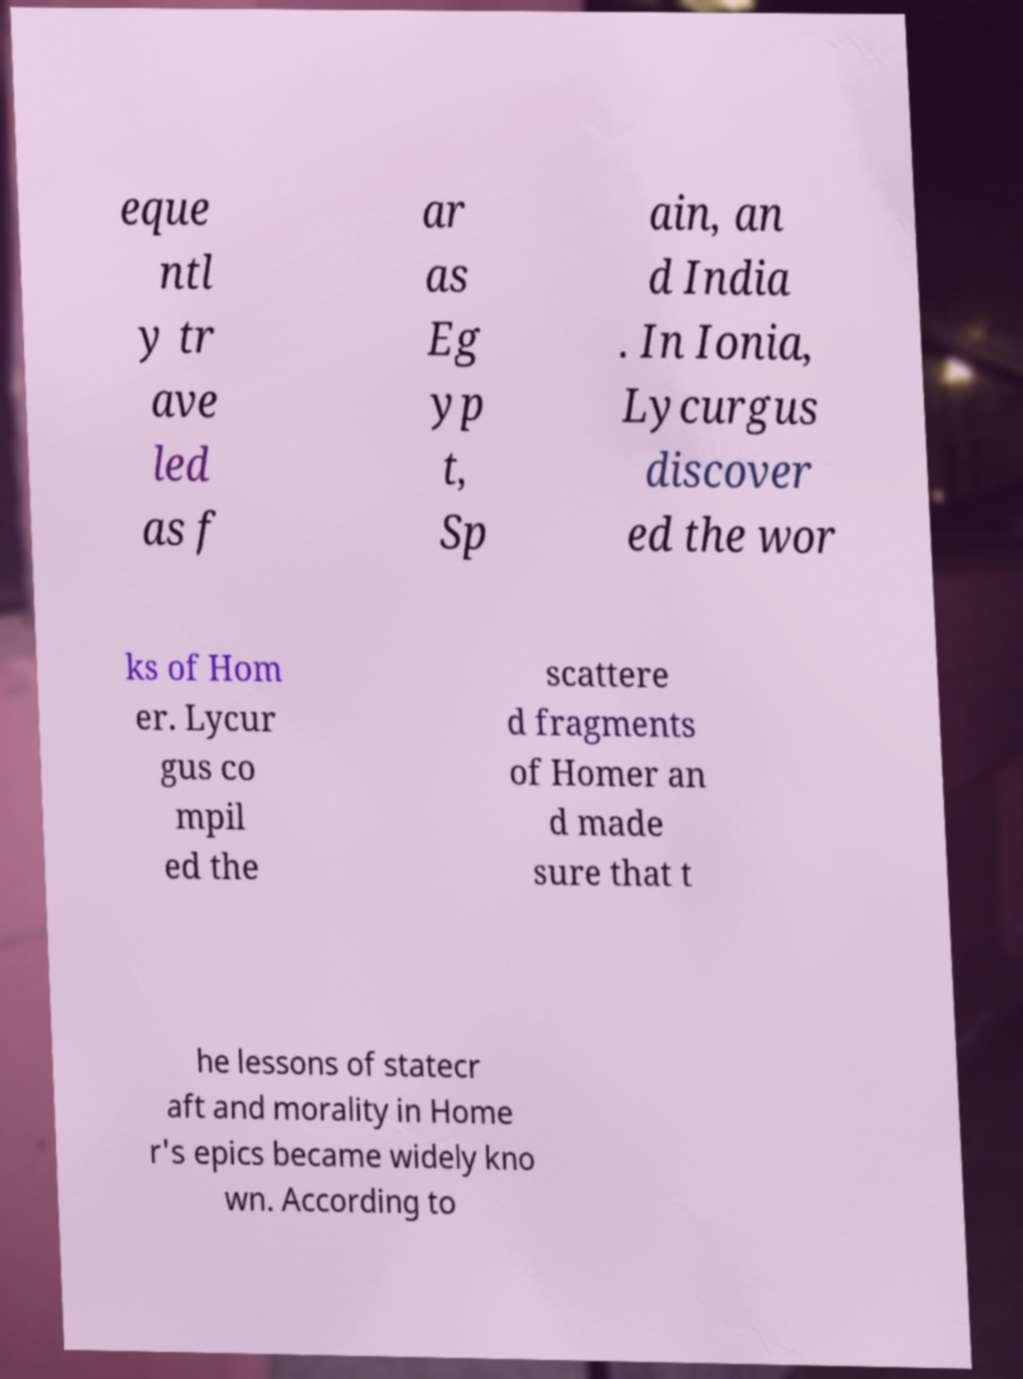Could you assist in decoding the text presented in this image and type it out clearly? eque ntl y tr ave led as f ar as Eg yp t, Sp ain, an d India . In Ionia, Lycurgus discover ed the wor ks of Hom er. Lycur gus co mpil ed the scattere d fragments of Homer an d made sure that t he lessons of statecr aft and morality in Home r's epics became widely kno wn. According to 